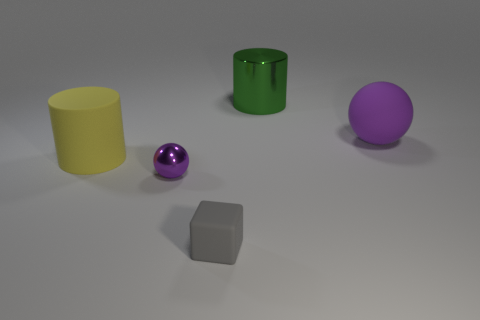Add 3 cyan matte cylinders. How many objects exist? 8 Subtract all spheres. How many objects are left? 3 Subtract 2 cylinders. How many cylinders are left? 0 Subtract all yellow cylinders. How many cylinders are left? 1 Subtract all purple blocks. How many yellow cylinders are left? 1 Subtract 0 purple blocks. How many objects are left? 5 Subtract all green spheres. Subtract all brown blocks. How many spheres are left? 2 Subtract all cylinders. Subtract all cylinders. How many objects are left? 1 Add 4 tiny blocks. How many tiny blocks are left? 5 Add 2 metallic cylinders. How many metallic cylinders exist? 3 